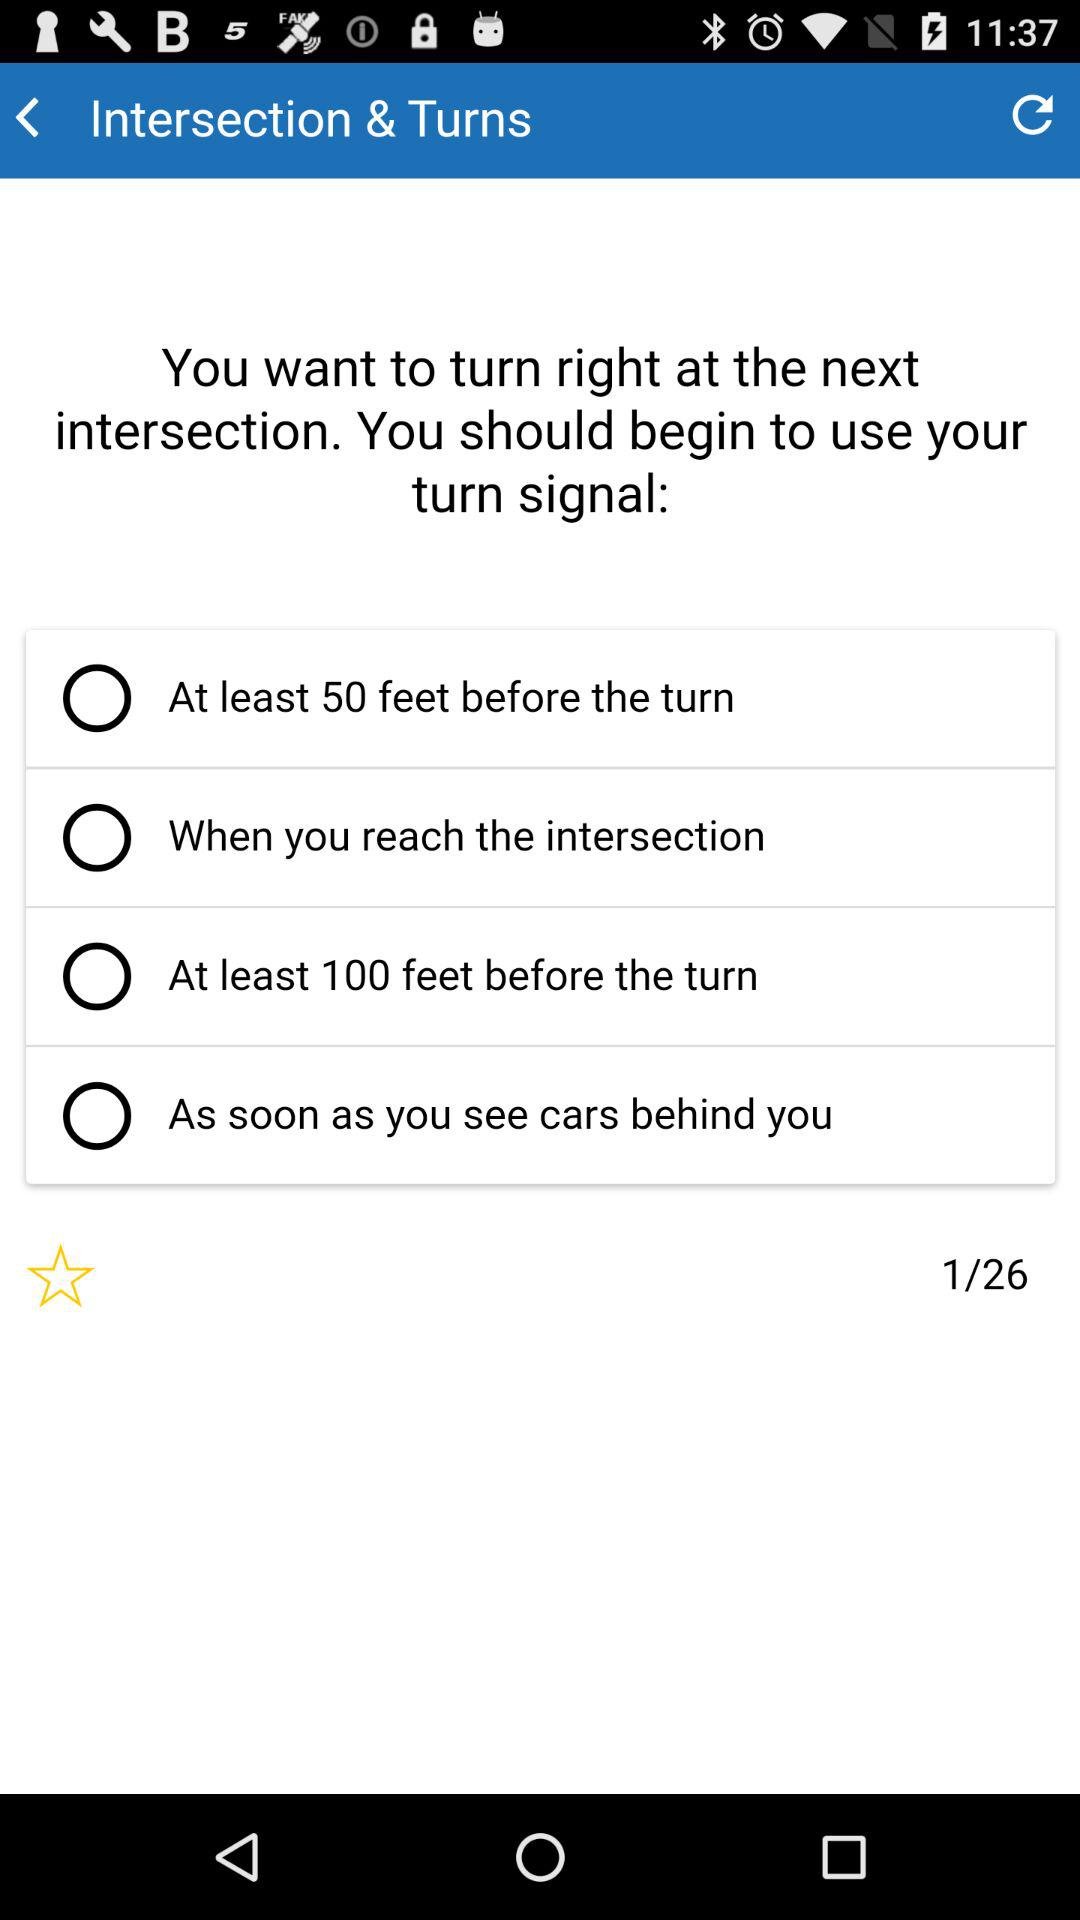How many questions in total are there? There are 26 questions in total. 